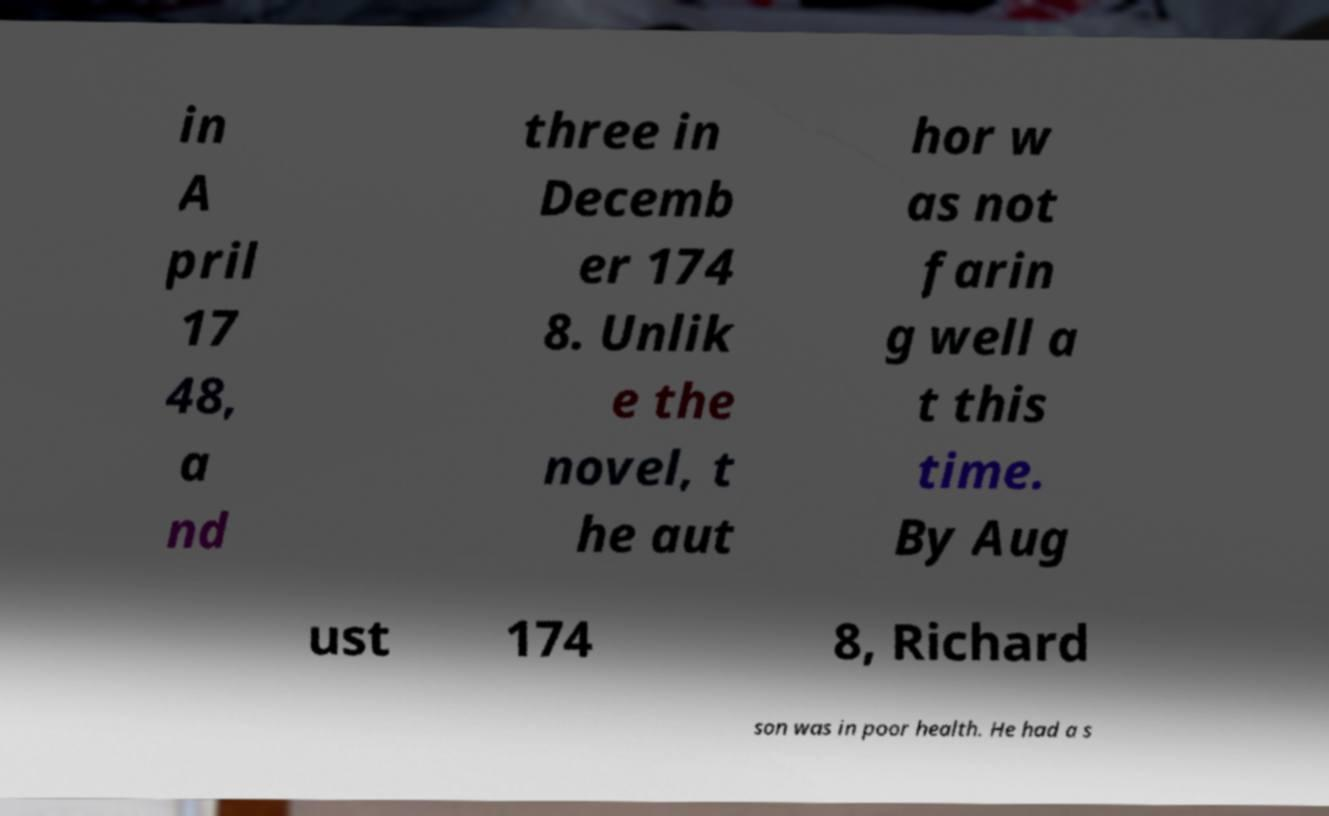For documentation purposes, I need the text within this image transcribed. Could you provide that? in A pril 17 48, a nd three in Decemb er 174 8. Unlik e the novel, t he aut hor w as not farin g well a t this time. By Aug ust 174 8, Richard son was in poor health. He had a s 